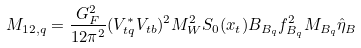<formula> <loc_0><loc_0><loc_500><loc_500>M _ { 1 2 , q } = \frac { G _ { F } ^ { 2 } } { 1 2 \pi ^ { 2 } } ( V _ { t q } ^ { * } V _ { t b } ) ^ { 2 } M _ { W } ^ { 2 } S _ { 0 } ( x _ { t } ) { B _ { B _ { q } } f _ { B _ { q } } ^ { 2 } M _ { B _ { q } } } \hat { \eta } _ { B }</formula> 